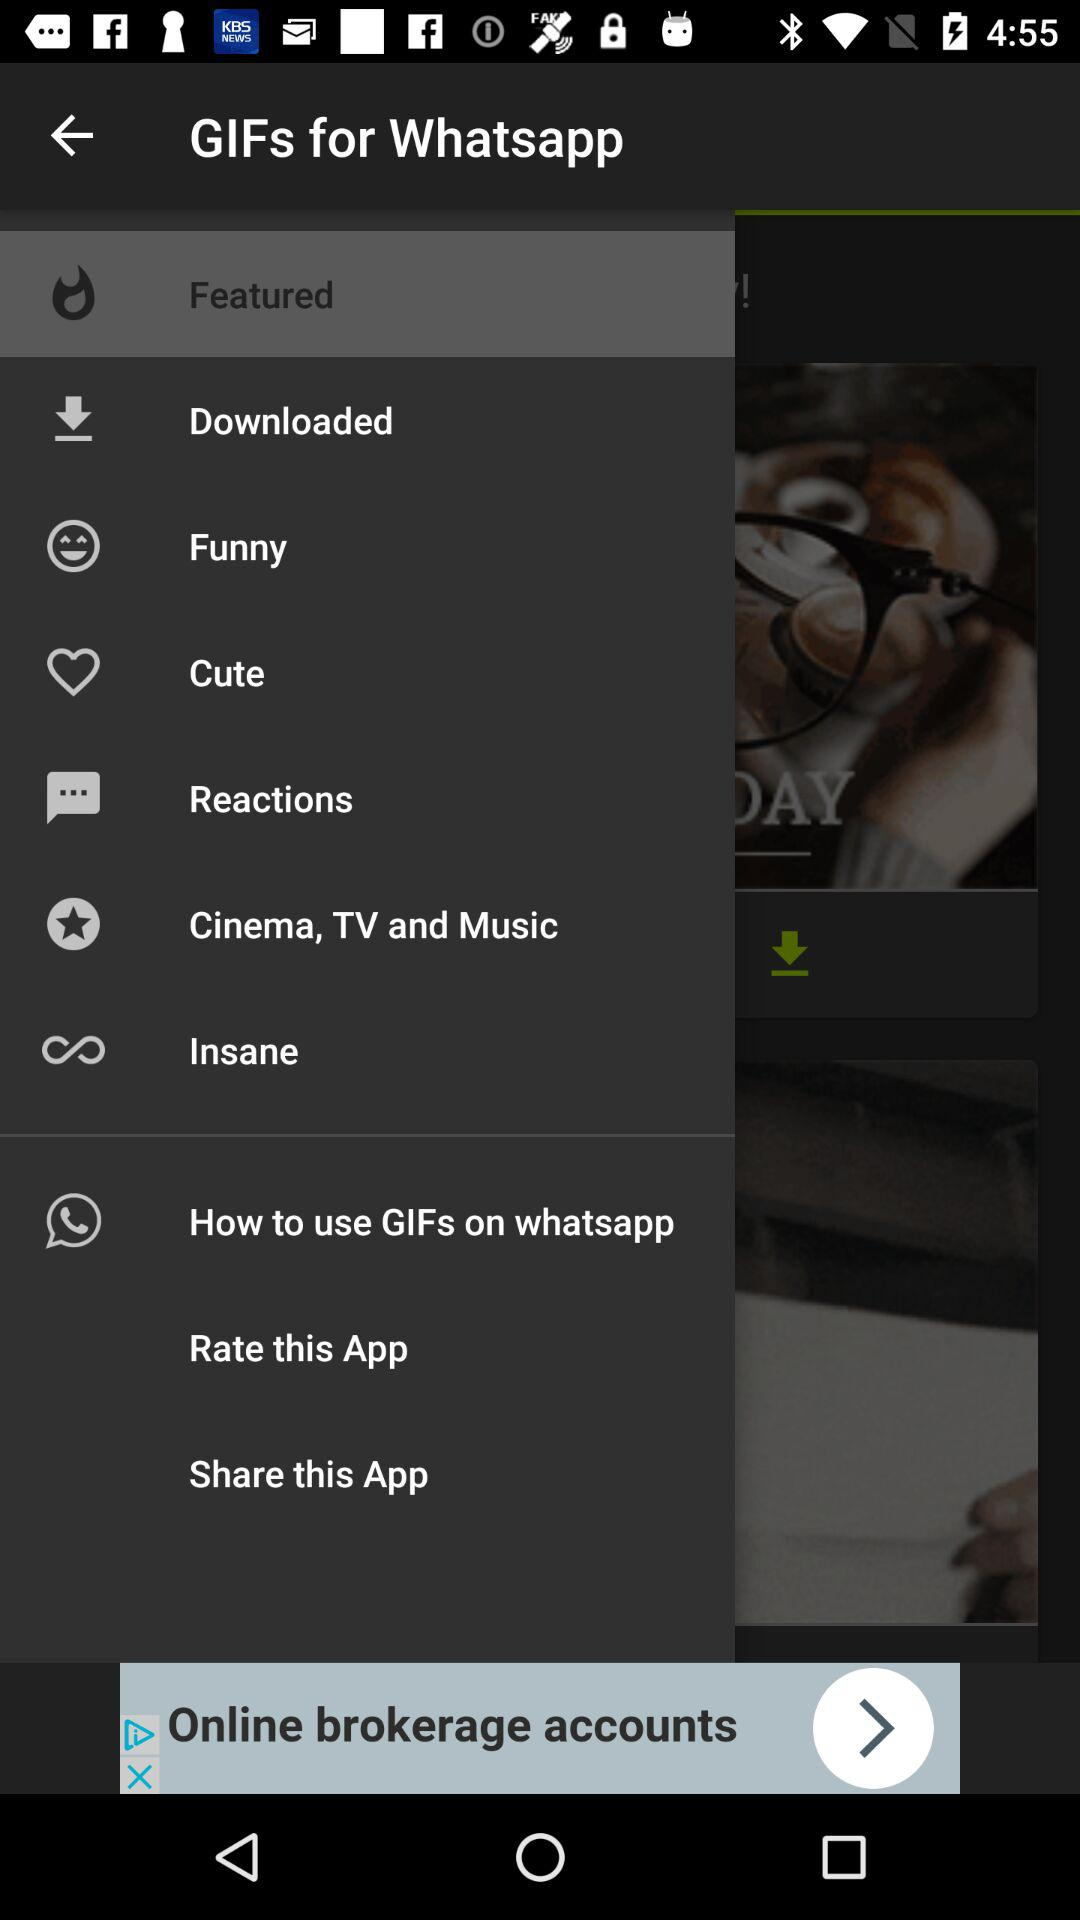What is the name of the application? The name of the application is "GIFs for Whatsapp". 